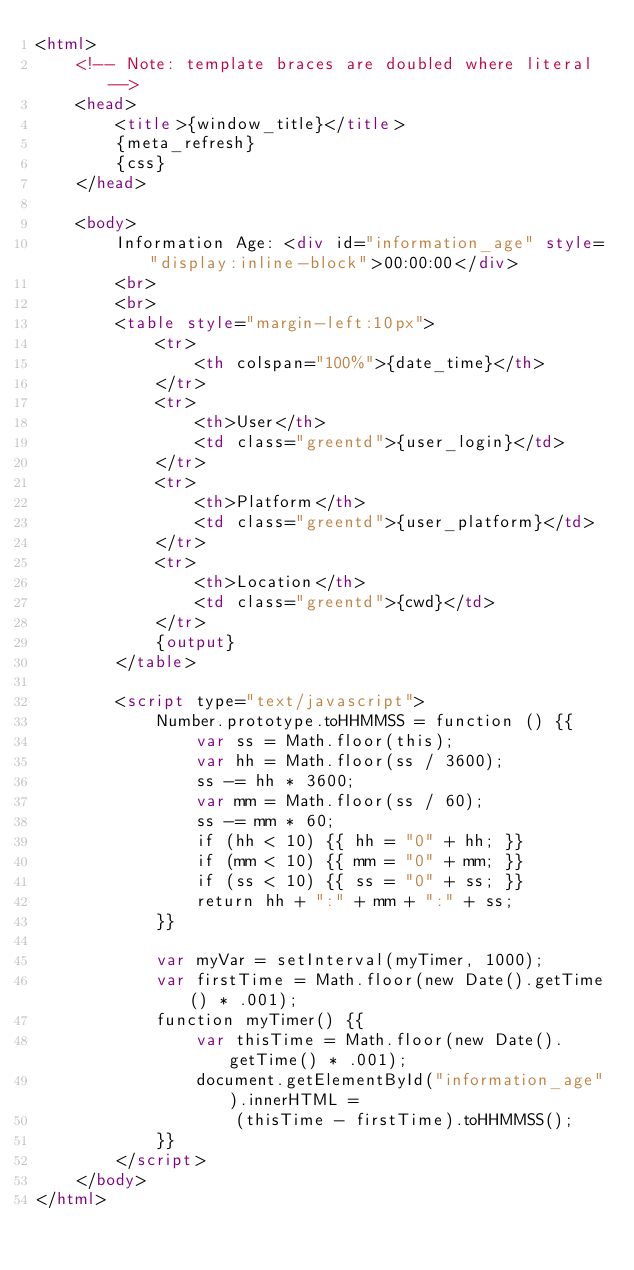<code> <loc_0><loc_0><loc_500><loc_500><_HTML_><html>
    <!-- Note: template braces are doubled where literal -->
    <head>
        <title>{window_title}</title>
        {meta_refresh}
        {css}
    </head>

    <body>
        Information Age: <div id="information_age" style="display:inline-block">00:00:00</div>
        <br>
        <br>
        <table style="margin-left:10px">
            <tr>
                <th colspan="100%">{date_time}</th>
            </tr>
            <tr>
                <th>User</th>
                <td class="greentd">{user_login}</td>
            </tr>
            <tr>
                <th>Platform</th>
                <td class="greentd">{user_platform}</td>
            </tr>
            <tr>
                <th>Location</th>
                <td class="greentd">{cwd}</td>
            </tr>
            {output}
        </table>

        <script type="text/javascript">
            Number.prototype.toHHMMSS = function () {{
                var ss = Math.floor(this);
                var hh = Math.floor(ss / 3600);
                ss -= hh * 3600;
                var mm = Math.floor(ss / 60);
                ss -= mm * 60;
                if (hh < 10) {{ hh = "0" + hh; }}
                if (mm < 10) {{ mm = "0" + mm; }}
                if (ss < 10) {{ ss = "0" + ss; }}
                return hh + ":" + mm + ":" + ss;
            }}

            var myVar = setInterval(myTimer, 1000);
            var firstTime = Math.floor(new Date().getTime() * .001);
            function myTimer() {{
                var thisTime = Math.floor(new Date().getTime() * .001);
                document.getElementById("information_age").innerHTML =
                    (thisTime - firstTime).toHHMMSS();
            }}
        </script>
    </body>
</html>
</code> 